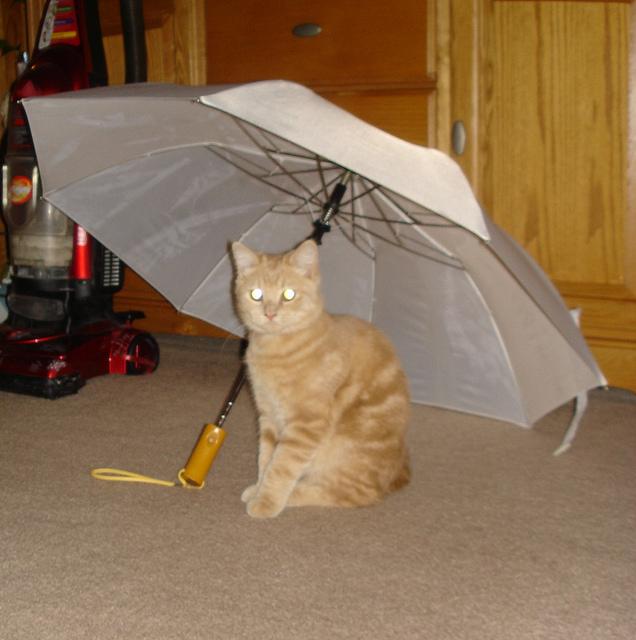What kind of animal is this?
Answer briefly. Cat. What color is the handle on the umbrella?
Give a very brief answer. Yellow. Is the cat afraid that it might rain?
Quick response, please. No. Are the cats eyes glowing?
Be succinct. Yes. What color is the cat?
Short answer required. Orange. 